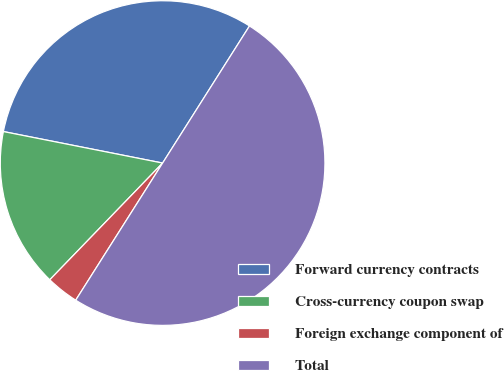Convert chart to OTSL. <chart><loc_0><loc_0><loc_500><loc_500><pie_chart><fcel>Forward currency contracts<fcel>Cross-currency coupon swap<fcel>Foreign exchange component of<fcel>Total<nl><fcel>30.88%<fcel>15.88%<fcel>3.24%<fcel>50.0%<nl></chart> 